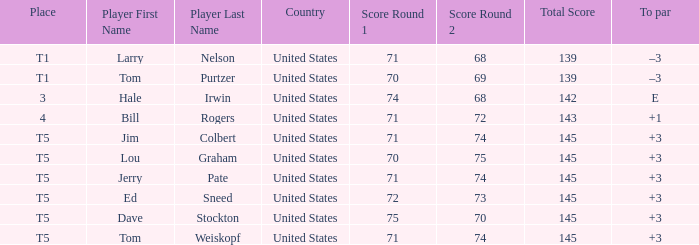What is the to par of player ed sneed, who has a t5 place? 3.0. Could you parse the entire table as a dict? {'header': ['Place', 'Player First Name', 'Player Last Name', 'Country', 'Score Round 1', 'Score Round 2', 'Total Score', 'To par'], 'rows': [['T1', 'Larry', 'Nelson', 'United States', '71', '68', '139', '–3'], ['T1', 'Tom', 'Purtzer', 'United States', '70', '69', '139', '–3'], ['3', 'Hale', 'Irwin', 'United States', '74', '68', '142', 'E'], ['4', 'Bill', 'Rogers', 'United States', '71', '72', '143', '+1'], ['T5', 'Jim', 'Colbert', 'United States', '71', '74', '145', '+3'], ['T5', 'Lou', 'Graham', 'United States', '70', '75', '145', '+3'], ['T5', 'Jerry', 'Pate', 'United States', '71', '74', '145', '+3'], ['T5', 'Ed', 'Sneed', 'United States', '72', '73', '145', '+3'], ['T5', 'Dave', 'Stockton', 'United States', '75', '70', '145', '+3'], ['T5', 'Tom', 'Weiskopf', 'United States', '71', '74', '145', '+3']]} 